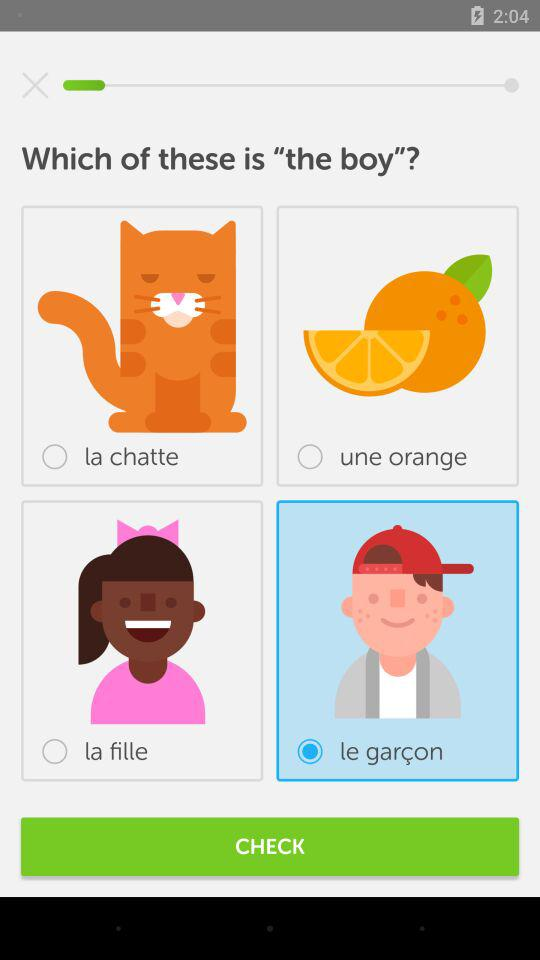Which is the boy?
Answer the question using a single word or phrase. Le garçon 